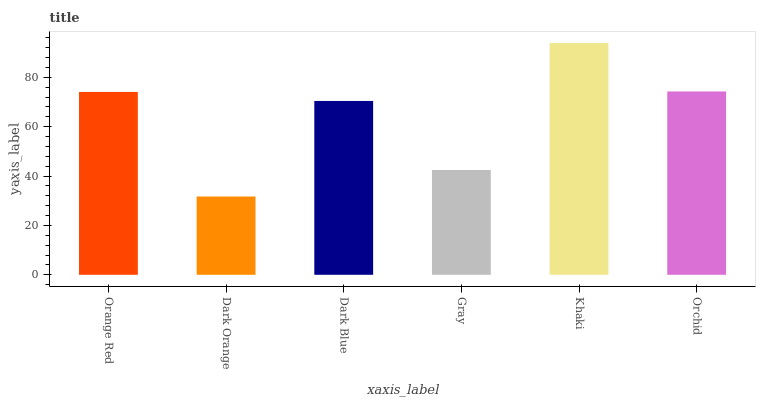Is Dark Orange the minimum?
Answer yes or no. Yes. Is Khaki the maximum?
Answer yes or no. Yes. Is Dark Blue the minimum?
Answer yes or no. No. Is Dark Blue the maximum?
Answer yes or no. No. Is Dark Blue greater than Dark Orange?
Answer yes or no. Yes. Is Dark Orange less than Dark Blue?
Answer yes or no. Yes. Is Dark Orange greater than Dark Blue?
Answer yes or no. No. Is Dark Blue less than Dark Orange?
Answer yes or no. No. Is Orange Red the high median?
Answer yes or no. Yes. Is Dark Blue the low median?
Answer yes or no. Yes. Is Dark Blue the high median?
Answer yes or no. No. Is Gray the low median?
Answer yes or no. No. 